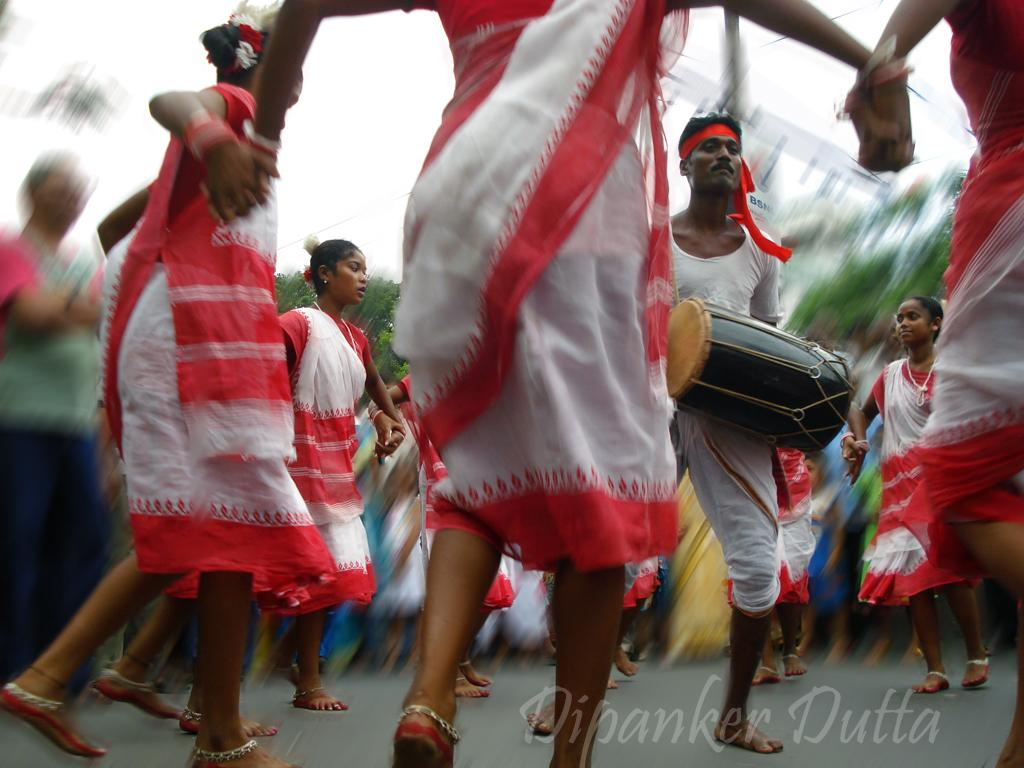What is happening in the image involving the group of people? The people are dancing in the image. Is there any musical accompaniment in the image? Yes, there is a man playing a drum in the image. What can be seen in the background of the image? The background of the image includes sky and trees. How would you describe the appearance of the background? The background appears blurry. Where is the sofa located in the image? There is no sofa present in the image. What color is the wrist of the person playing the drum? The image does not provide enough detail to determine the color of the wrist of the person playing the drum. 